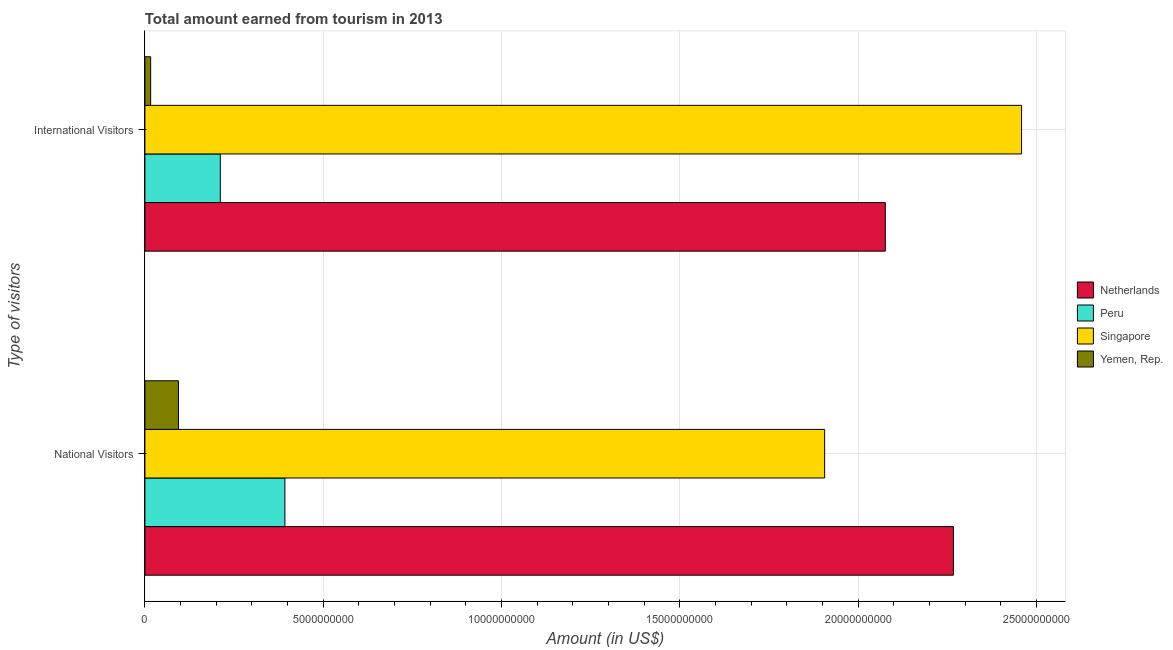How many groups of bars are there?
Offer a terse response. 2. Are the number of bars per tick equal to the number of legend labels?
Offer a terse response. Yes. Are the number of bars on each tick of the Y-axis equal?
Provide a succinct answer. Yes. How many bars are there on the 1st tick from the top?
Give a very brief answer. 4. How many bars are there on the 2nd tick from the bottom?
Offer a very short reply. 4. What is the label of the 2nd group of bars from the top?
Keep it short and to the point. National Visitors. What is the amount earned from international visitors in Netherlands?
Your answer should be compact. 2.08e+1. Across all countries, what is the maximum amount earned from international visitors?
Your answer should be very brief. 2.46e+1. Across all countries, what is the minimum amount earned from national visitors?
Offer a terse response. 9.40e+08. In which country was the amount earned from international visitors maximum?
Keep it short and to the point. Singapore. In which country was the amount earned from international visitors minimum?
Your answer should be very brief. Yemen, Rep. What is the total amount earned from international visitors in the graph?
Make the answer very short. 4.76e+1. What is the difference between the amount earned from international visitors in Netherlands and that in Yemen, Rep.?
Offer a terse response. 2.06e+1. What is the difference between the amount earned from international visitors in Peru and the amount earned from national visitors in Netherlands?
Offer a terse response. -2.06e+1. What is the average amount earned from national visitors per country?
Ensure brevity in your answer.  1.16e+1. What is the difference between the amount earned from national visitors and amount earned from international visitors in Yemen, Rep.?
Your response must be concise. 7.79e+08. In how many countries, is the amount earned from international visitors greater than 12000000000 US$?
Ensure brevity in your answer.  2. What is the ratio of the amount earned from national visitors in Netherlands to that in Peru?
Make the answer very short. 5.78. Is the amount earned from international visitors in Singapore less than that in Peru?
Make the answer very short. No. In how many countries, is the amount earned from national visitors greater than the average amount earned from national visitors taken over all countries?
Offer a very short reply. 2. What does the 3rd bar from the bottom in International Visitors represents?
Keep it short and to the point. Singapore. How many bars are there?
Offer a terse response. 8. How many countries are there in the graph?
Ensure brevity in your answer.  4. Are the values on the major ticks of X-axis written in scientific E-notation?
Ensure brevity in your answer.  No. Does the graph contain grids?
Provide a succinct answer. Yes. How many legend labels are there?
Keep it short and to the point. 4. What is the title of the graph?
Make the answer very short. Total amount earned from tourism in 2013. What is the label or title of the X-axis?
Provide a short and direct response. Amount (in US$). What is the label or title of the Y-axis?
Your answer should be compact. Type of visitors. What is the Amount (in US$) in Netherlands in National Visitors?
Give a very brief answer. 2.27e+1. What is the Amount (in US$) in Peru in National Visitors?
Offer a very short reply. 3.92e+09. What is the Amount (in US$) in Singapore in National Visitors?
Make the answer very short. 1.91e+1. What is the Amount (in US$) of Yemen, Rep. in National Visitors?
Provide a succinct answer. 9.40e+08. What is the Amount (in US$) of Netherlands in International Visitors?
Provide a succinct answer. 2.08e+1. What is the Amount (in US$) of Peru in International Visitors?
Your answer should be very brief. 2.11e+09. What is the Amount (in US$) of Singapore in International Visitors?
Ensure brevity in your answer.  2.46e+1. What is the Amount (in US$) in Yemen, Rep. in International Visitors?
Offer a very short reply. 1.61e+08. Across all Type of visitors, what is the maximum Amount (in US$) in Netherlands?
Ensure brevity in your answer.  2.27e+1. Across all Type of visitors, what is the maximum Amount (in US$) of Peru?
Your response must be concise. 3.92e+09. Across all Type of visitors, what is the maximum Amount (in US$) in Singapore?
Offer a very short reply. 2.46e+1. Across all Type of visitors, what is the maximum Amount (in US$) of Yemen, Rep.?
Your response must be concise. 9.40e+08. Across all Type of visitors, what is the minimum Amount (in US$) in Netherlands?
Offer a terse response. 2.08e+1. Across all Type of visitors, what is the minimum Amount (in US$) of Peru?
Make the answer very short. 2.11e+09. Across all Type of visitors, what is the minimum Amount (in US$) of Singapore?
Offer a terse response. 1.91e+1. Across all Type of visitors, what is the minimum Amount (in US$) in Yemen, Rep.?
Your answer should be compact. 1.61e+08. What is the total Amount (in US$) of Netherlands in the graph?
Provide a short and direct response. 4.34e+1. What is the total Amount (in US$) in Peru in the graph?
Keep it short and to the point. 6.04e+09. What is the total Amount (in US$) of Singapore in the graph?
Offer a very short reply. 4.36e+1. What is the total Amount (in US$) of Yemen, Rep. in the graph?
Keep it short and to the point. 1.10e+09. What is the difference between the Amount (in US$) of Netherlands in National Visitors and that in International Visitors?
Keep it short and to the point. 1.91e+09. What is the difference between the Amount (in US$) of Peru in National Visitors and that in International Visitors?
Offer a terse response. 1.81e+09. What is the difference between the Amount (in US$) of Singapore in National Visitors and that in International Visitors?
Provide a succinct answer. -5.52e+09. What is the difference between the Amount (in US$) in Yemen, Rep. in National Visitors and that in International Visitors?
Offer a very short reply. 7.79e+08. What is the difference between the Amount (in US$) in Netherlands in National Visitors and the Amount (in US$) in Peru in International Visitors?
Provide a succinct answer. 2.06e+1. What is the difference between the Amount (in US$) of Netherlands in National Visitors and the Amount (in US$) of Singapore in International Visitors?
Offer a very short reply. -1.91e+09. What is the difference between the Amount (in US$) of Netherlands in National Visitors and the Amount (in US$) of Yemen, Rep. in International Visitors?
Keep it short and to the point. 2.25e+1. What is the difference between the Amount (in US$) of Peru in National Visitors and the Amount (in US$) of Singapore in International Visitors?
Offer a terse response. -2.07e+1. What is the difference between the Amount (in US$) of Peru in National Visitors and the Amount (in US$) of Yemen, Rep. in International Visitors?
Make the answer very short. 3.76e+09. What is the difference between the Amount (in US$) of Singapore in National Visitors and the Amount (in US$) of Yemen, Rep. in International Visitors?
Provide a short and direct response. 1.89e+1. What is the average Amount (in US$) of Netherlands per Type of visitors?
Your answer should be compact. 2.17e+1. What is the average Amount (in US$) in Peru per Type of visitors?
Your answer should be compact. 3.02e+09. What is the average Amount (in US$) in Singapore per Type of visitors?
Ensure brevity in your answer.  2.18e+1. What is the average Amount (in US$) of Yemen, Rep. per Type of visitors?
Provide a short and direct response. 5.50e+08. What is the difference between the Amount (in US$) of Netherlands and Amount (in US$) of Peru in National Visitors?
Your response must be concise. 1.87e+1. What is the difference between the Amount (in US$) in Netherlands and Amount (in US$) in Singapore in National Visitors?
Keep it short and to the point. 3.61e+09. What is the difference between the Amount (in US$) of Netherlands and Amount (in US$) of Yemen, Rep. in National Visitors?
Offer a terse response. 2.17e+1. What is the difference between the Amount (in US$) in Peru and Amount (in US$) in Singapore in National Visitors?
Your answer should be compact. -1.51e+1. What is the difference between the Amount (in US$) in Peru and Amount (in US$) in Yemen, Rep. in National Visitors?
Your answer should be compact. 2.98e+09. What is the difference between the Amount (in US$) in Singapore and Amount (in US$) in Yemen, Rep. in National Visitors?
Keep it short and to the point. 1.81e+1. What is the difference between the Amount (in US$) of Netherlands and Amount (in US$) of Peru in International Visitors?
Provide a succinct answer. 1.86e+1. What is the difference between the Amount (in US$) of Netherlands and Amount (in US$) of Singapore in International Visitors?
Ensure brevity in your answer.  -3.82e+09. What is the difference between the Amount (in US$) in Netherlands and Amount (in US$) in Yemen, Rep. in International Visitors?
Provide a short and direct response. 2.06e+1. What is the difference between the Amount (in US$) of Peru and Amount (in US$) of Singapore in International Visitors?
Keep it short and to the point. -2.25e+1. What is the difference between the Amount (in US$) in Peru and Amount (in US$) in Yemen, Rep. in International Visitors?
Your answer should be compact. 1.95e+09. What is the difference between the Amount (in US$) in Singapore and Amount (in US$) in Yemen, Rep. in International Visitors?
Provide a short and direct response. 2.44e+1. What is the ratio of the Amount (in US$) of Netherlands in National Visitors to that in International Visitors?
Offer a very short reply. 1.09. What is the ratio of the Amount (in US$) of Peru in National Visitors to that in International Visitors?
Keep it short and to the point. 1.86. What is the ratio of the Amount (in US$) in Singapore in National Visitors to that in International Visitors?
Make the answer very short. 0.78. What is the ratio of the Amount (in US$) in Yemen, Rep. in National Visitors to that in International Visitors?
Your answer should be very brief. 5.84. What is the difference between the highest and the second highest Amount (in US$) of Netherlands?
Your answer should be very brief. 1.91e+09. What is the difference between the highest and the second highest Amount (in US$) of Peru?
Your answer should be compact. 1.81e+09. What is the difference between the highest and the second highest Amount (in US$) in Singapore?
Offer a very short reply. 5.52e+09. What is the difference between the highest and the second highest Amount (in US$) in Yemen, Rep.?
Make the answer very short. 7.79e+08. What is the difference between the highest and the lowest Amount (in US$) of Netherlands?
Ensure brevity in your answer.  1.91e+09. What is the difference between the highest and the lowest Amount (in US$) in Peru?
Keep it short and to the point. 1.81e+09. What is the difference between the highest and the lowest Amount (in US$) of Singapore?
Make the answer very short. 5.52e+09. What is the difference between the highest and the lowest Amount (in US$) in Yemen, Rep.?
Offer a terse response. 7.79e+08. 